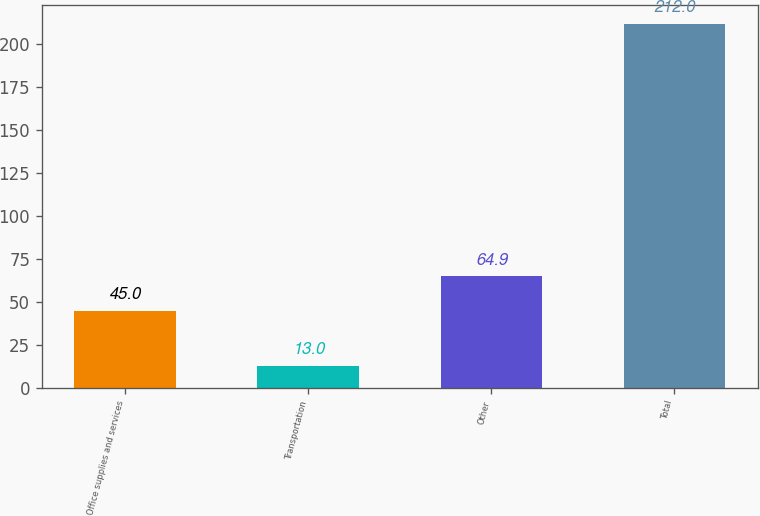Convert chart to OTSL. <chart><loc_0><loc_0><loc_500><loc_500><bar_chart><fcel>Office supplies and services<fcel>Transportation<fcel>Other<fcel>Total<nl><fcel>45<fcel>13<fcel>64.9<fcel>212<nl></chart> 